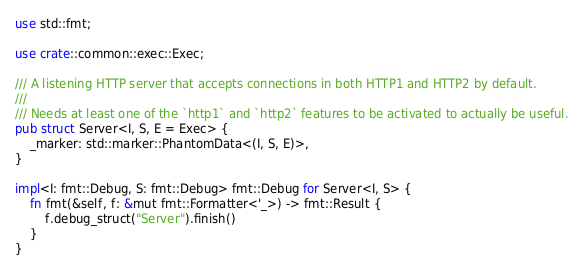Convert code to text. <code><loc_0><loc_0><loc_500><loc_500><_Rust_>use std::fmt;

use crate::common::exec::Exec;

/// A listening HTTP server that accepts connections in both HTTP1 and HTTP2 by default.
///
/// Needs at least one of the `http1` and `http2` features to be activated to actually be useful.
pub struct Server<I, S, E = Exec> {
    _marker: std::marker::PhantomData<(I, S, E)>,
}

impl<I: fmt::Debug, S: fmt::Debug> fmt::Debug for Server<I, S> {
    fn fmt(&self, f: &mut fmt::Formatter<'_>) -> fmt::Result {
        f.debug_struct("Server").finish()
    }
}
</code> 